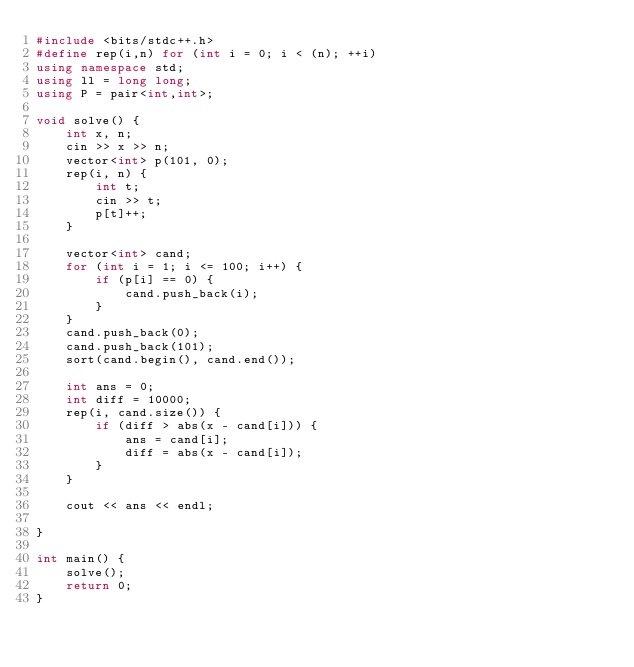Convert code to text. <code><loc_0><loc_0><loc_500><loc_500><_C++_>#include <bits/stdc++.h>
#define rep(i,n) for (int i = 0; i < (n); ++i)
using namespace std;
using ll = long long;
using P = pair<int,int>;

void solve() {
    int x, n;
    cin >> x >> n;
    vector<int> p(101, 0);
    rep(i, n) {
        int t;
        cin >> t;
        p[t]++;
    }

    vector<int> cand;
    for (int i = 1; i <= 100; i++) {
        if (p[i] == 0) {
            cand.push_back(i);
        }
    }
    cand.push_back(0);
    cand.push_back(101);
    sort(cand.begin(), cand.end());

    int ans = 0;
    int diff = 10000;
    rep(i, cand.size()) {
        if (diff > abs(x - cand[i])) {
            ans = cand[i];
            diff = abs(x - cand[i]);
        }
    }

    cout << ans << endl;

}

int main() {
    solve();
    return 0;
}
</code> 